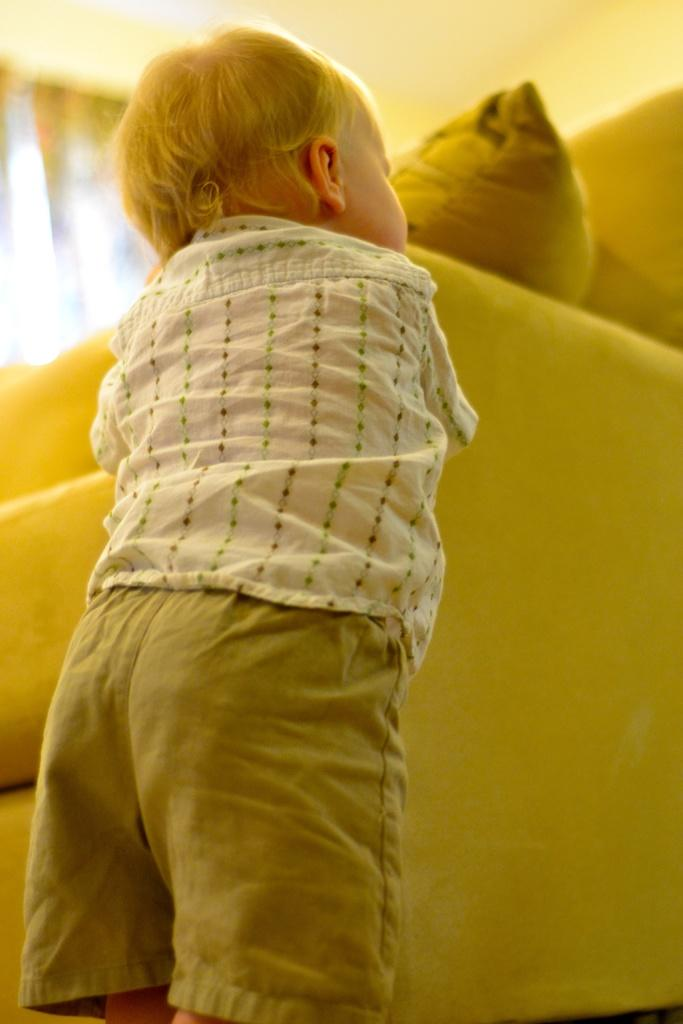What is the main subject of the image? There is a child in the image. Where is the child located in relation to the furniture? The child is standing beside a sofa. What is the condition of the sofa in the image? The sofa contains a cushion, and there is a curtain visible on the backside of the sofa. What type of structure is present in the image? A roof is present in the image. What type of farm animals can be seen grazing in the image? There are no farm animals present in the image; it features a child standing beside a sofa. How many beads are visible on the curtain in the image? There is no mention of beads on the curtain in the image; it only states that there is a curtain visible on the backside of the sofa. 